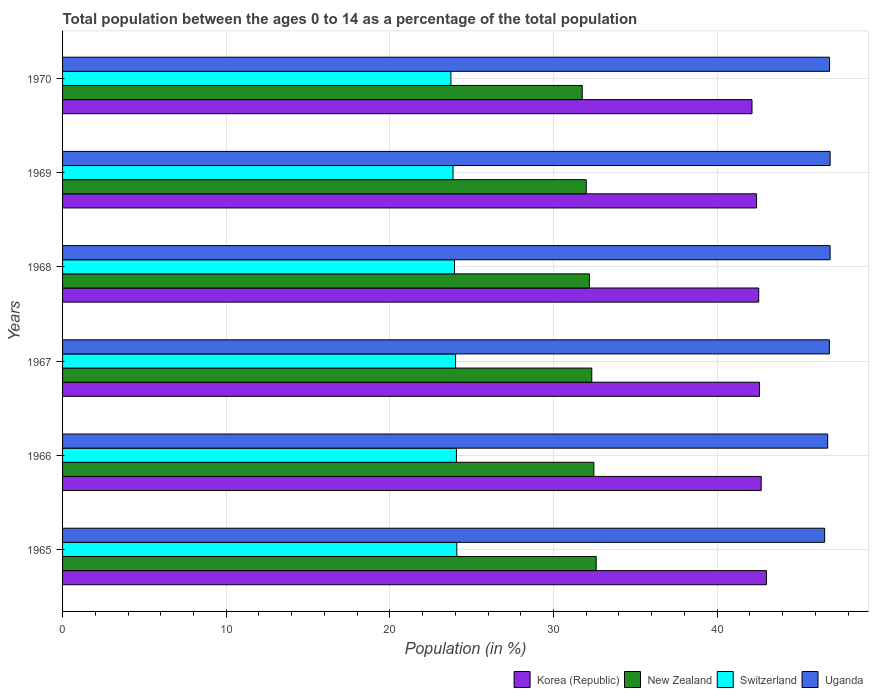Are the number of bars on each tick of the Y-axis equal?
Provide a succinct answer. Yes. How many bars are there on the 1st tick from the top?
Your answer should be compact. 4. What is the label of the 4th group of bars from the top?
Your answer should be very brief. 1967. In how many cases, is the number of bars for a given year not equal to the number of legend labels?
Ensure brevity in your answer.  0. What is the percentage of the population ages 0 to 14 in Uganda in 1965?
Provide a short and direct response. 46.57. Across all years, what is the maximum percentage of the population ages 0 to 14 in New Zealand?
Keep it short and to the point. 32.61. Across all years, what is the minimum percentage of the population ages 0 to 14 in Uganda?
Keep it short and to the point. 46.57. In which year was the percentage of the population ages 0 to 14 in Korea (Republic) maximum?
Provide a succinct answer. 1965. What is the total percentage of the population ages 0 to 14 in Korea (Republic) in the graph?
Keep it short and to the point. 255.38. What is the difference between the percentage of the population ages 0 to 14 in Uganda in 1965 and that in 1970?
Keep it short and to the point. -0.3. What is the difference between the percentage of the population ages 0 to 14 in Uganda in 1965 and the percentage of the population ages 0 to 14 in Switzerland in 1968?
Offer a terse response. 22.62. What is the average percentage of the population ages 0 to 14 in Uganda per year?
Provide a succinct answer. 46.81. In the year 1969, what is the difference between the percentage of the population ages 0 to 14 in New Zealand and percentage of the population ages 0 to 14 in Uganda?
Keep it short and to the point. -14.9. In how many years, is the percentage of the population ages 0 to 14 in Switzerland greater than 12 ?
Your response must be concise. 6. What is the ratio of the percentage of the population ages 0 to 14 in Uganda in 1967 to that in 1968?
Keep it short and to the point. 1. Is the difference between the percentage of the population ages 0 to 14 in New Zealand in 1969 and 1970 greater than the difference between the percentage of the population ages 0 to 14 in Uganda in 1969 and 1970?
Your answer should be compact. Yes. What is the difference between the highest and the second highest percentage of the population ages 0 to 14 in New Zealand?
Your answer should be compact. 0.14. What is the difference between the highest and the lowest percentage of the population ages 0 to 14 in Switzerland?
Keep it short and to the point. 0.36. Is it the case that in every year, the sum of the percentage of the population ages 0 to 14 in Switzerland and percentage of the population ages 0 to 14 in New Zealand is greater than the sum of percentage of the population ages 0 to 14 in Uganda and percentage of the population ages 0 to 14 in Korea (Republic)?
Give a very brief answer. No. What does the 2nd bar from the top in 1966 represents?
Your response must be concise. Switzerland. What does the 1st bar from the bottom in 1969 represents?
Offer a terse response. Korea (Republic). Is it the case that in every year, the sum of the percentage of the population ages 0 to 14 in Uganda and percentage of the population ages 0 to 14 in Switzerland is greater than the percentage of the population ages 0 to 14 in Korea (Republic)?
Provide a succinct answer. Yes. Are all the bars in the graph horizontal?
Your answer should be compact. Yes. Are the values on the major ticks of X-axis written in scientific E-notation?
Keep it short and to the point. No. Does the graph contain any zero values?
Make the answer very short. No. Does the graph contain grids?
Provide a short and direct response. Yes. Where does the legend appear in the graph?
Provide a succinct answer. Bottom right. How many legend labels are there?
Ensure brevity in your answer.  4. What is the title of the graph?
Your response must be concise. Total population between the ages 0 to 14 as a percentage of the total population. Does "North America" appear as one of the legend labels in the graph?
Your answer should be very brief. No. What is the label or title of the Y-axis?
Your response must be concise. Years. What is the Population (in %) in Korea (Republic) in 1965?
Provide a succinct answer. 43.01. What is the Population (in %) of New Zealand in 1965?
Make the answer very short. 32.61. What is the Population (in %) of Switzerland in 1965?
Your answer should be compact. 24.09. What is the Population (in %) of Uganda in 1965?
Your answer should be compact. 46.57. What is the Population (in %) in Korea (Republic) in 1966?
Give a very brief answer. 42.69. What is the Population (in %) in New Zealand in 1966?
Offer a very short reply. 32.47. What is the Population (in %) in Switzerland in 1966?
Ensure brevity in your answer.  24.07. What is the Population (in %) in Uganda in 1966?
Keep it short and to the point. 46.76. What is the Population (in %) in Korea (Republic) in 1967?
Give a very brief answer. 42.59. What is the Population (in %) of New Zealand in 1967?
Ensure brevity in your answer.  32.34. What is the Population (in %) of Switzerland in 1967?
Make the answer very short. 24.02. What is the Population (in %) in Uganda in 1967?
Your answer should be very brief. 46.86. What is the Population (in %) in Korea (Republic) in 1968?
Give a very brief answer. 42.54. What is the Population (in %) in New Zealand in 1968?
Ensure brevity in your answer.  32.19. What is the Population (in %) of Switzerland in 1968?
Your answer should be compact. 23.95. What is the Population (in %) in Uganda in 1968?
Ensure brevity in your answer.  46.9. What is the Population (in %) of Korea (Republic) in 1969?
Your answer should be compact. 42.41. What is the Population (in %) in New Zealand in 1969?
Provide a short and direct response. 32. What is the Population (in %) in Switzerland in 1969?
Your response must be concise. 23.86. What is the Population (in %) of Uganda in 1969?
Provide a short and direct response. 46.9. What is the Population (in %) of Korea (Republic) in 1970?
Provide a succinct answer. 42.13. What is the Population (in %) of New Zealand in 1970?
Give a very brief answer. 31.76. What is the Population (in %) of Switzerland in 1970?
Offer a terse response. 23.73. What is the Population (in %) in Uganda in 1970?
Your response must be concise. 46.87. Across all years, what is the maximum Population (in %) in Korea (Republic)?
Provide a succinct answer. 43.01. Across all years, what is the maximum Population (in %) of New Zealand?
Ensure brevity in your answer.  32.61. Across all years, what is the maximum Population (in %) of Switzerland?
Ensure brevity in your answer.  24.09. Across all years, what is the maximum Population (in %) of Uganda?
Make the answer very short. 46.9. Across all years, what is the minimum Population (in %) of Korea (Republic)?
Your answer should be compact. 42.13. Across all years, what is the minimum Population (in %) in New Zealand?
Provide a succinct answer. 31.76. Across all years, what is the minimum Population (in %) of Switzerland?
Your answer should be very brief. 23.73. Across all years, what is the minimum Population (in %) of Uganda?
Give a very brief answer. 46.57. What is the total Population (in %) in Korea (Republic) in the graph?
Offer a terse response. 255.38. What is the total Population (in %) in New Zealand in the graph?
Ensure brevity in your answer.  193.37. What is the total Population (in %) of Switzerland in the graph?
Ensure brevity in your answer.  143.72. What is the total Population (in %) of Uganda in the graph?
Provide a short and direct response. 280.86. What is the difference between the Population (in %) in Korea (Republic) in 1965 and that in 1966?
Ensure brevity in your answer.  0.32. What is the difference between the Population (in %) of New Zealand in 1965 and that in 1966?
Offer a terse response. 0.14. What is the difference between the Population (in %) of Switzerland in 1965 and that in 1966?
Your answer should be very brief. 0.02. What is the difference between the Population (in %) in Uganda in 1965 and that in 1966?
Your answer should be very brief. -0.19. What is the difference between the Population (in %) in Korea (Republic) in 1965 and that in 1967?
Make the answer very short. 0.42. What is the difference between the Population (in %) of New Zealand in 1965 and that in 1967?
Your response must be concise. 0.27. What is the difference between the Population (in %) in Switzerland in 1965 and that in 1967?
Your response must be concise. 0.07. What is the difference between the Population (in %) in Uganda in 1965 and that in 1967?
Offer a very short reply. -0.29. What is the difference between the Population (in %) in Korea (Republic) in 1965 and that in 1968?
Keep it short and to the point. 0.47. What is the difference between the Population (in %) of New Zealand in 1965 and that in 1968?
Your response must be concise. 0.42. What is the difference between the Population (in %) of Switzerland in 1965 and that in 1968?
Make the answer very short. 0.14. What is the difference between the Population (in %) of Uganda in 1965 and that in 1968?
Provide a succinct answer. -0.33. What is the difference between the Population (in %) of Korea (Republic) in 1965 and that in 1969?
Your answer should be very brief. 0.61. What is the difference between the Population (in %) of New Zealand in 1965 and that in 1969?
Provide a succinct answer. 0.61. What is the difference between the Population (in %) in Switzerland in 1965 and that in 1969?
Offer a terse response. 0.23. What is the difference between the Population (in %) in Uganda in 1965 and that in 1969?
Give a very brief answer. -0.33. What is the difference between the Population (in %) of Korea (Republic) in 1965 and that in 1970?
Your answer should be compact. 0.88. What is the difference between the Population (in %) in New Zealand in 1965 and that in 1970?
Provide a short and direct response. 0.85. What is the difference between the Population (in %) in Switzerland in 1965 and that in 1970?
Your answer should be compact. 0.36. What is the difference between the Population (in %) in Uganda in 1965 and that in 1970?
Provide a succinct answer. -0.3. What is the difference between the Population (in %) in Korea (Republic) in 1966 and that in 1967?
Keep it short and to the point. 0.1. What is the difference between the Population (in %) in New Zealand in 1966 and that in 1967?
Offer a terse response. 0.13. What is the difference between the Population (in %) of Switzerland in 1966 and that in 1967?
Provide a succinct answer. 0.05. What is the difference between the Population (in %) of Uganda in 1966 and that in 1967?
Provide a succinct answer. -0.1. What is the difference between the Population (in %) in Korea (Republic) in 1966 and that in 1968?
Provide a succinct answer. 0.15. What is the difference between the Population (in %) in New Zealand in 1966 and that in 1968?
Provide a short and direct response. 0.27. What is the difference between the Population (in %) of Switzerland in 1966 and that in 1968?
Offer a very short reply. 0.12. What is the difference between the Population (in %) of Uganda in 1966 and that in 1968?
Make the answer very short. -0.15. What is the difference between the Population (in %) in Korea (Republic) in 1966 and that in 1969?
Your response must be concise. 0.28. What is the difference between the Population (in %) of New Zealand in 1966 and that in 1969?
Ensure brevity in your answer.  0.46. What is the difference between the Population (in %) of Switzerland in 1966 and that in 1969?
Your answer should be very brief. 0.21. What is the difference between the Population (in %) of Uganda in 1966 and that in 1969?
Your answer should be very brief. -0.15. What is the difference between the Population (in %) of Korea (Republic) in 1966 and that in 1970?
Your answer should be very brief. 0.56. What is the difference between the Population (in %) in New Zealand in 1966 and that in 1970?
Keep it short and to the point. 0.71. What is the difference between the Population (in %) of Switzerland in 1966 and that in 1970?
Your response must be concise. 0.34. What is the difference between the Population (in %) in Uganda in 1966 and that in 1970?
Give a very brief answer. -0.11. What is the difference between the Population (in %) of Korea (Republic) in 1967 and that in 1968?
Keep it short and to the point. 0.05. What is the difference between the Population (in %) of New Zealand in 1967 and that in 1968?
Provide a short and direct response. 0.14. What is the difference between the Population (in %) of Switzerland in 1967 and that in 1968?
Make the answer very short. 0.07. What is the difference between the Population (in %) in Uganda in 1967 and that in 1968?
Make the answer very short. -0.04. What is the difference between the Population (in %) in Korea (Republic) in 1967 and that in 1969?
Make the answer very short. 0.18. What is the difference between the Population (in %) of New Zealand in 1967 and that in 1969?
Offer a very short reply. 0.34. What is the difference between the Population (in %) in Switzerland in 1967 and that in 1969?
Provide a short and direct response. 0.16. What is the difference between the Population (in %) of Uganda in 1967 and that in 1969?
Ensure brevity in your answer.  -0.04. What is the difference between the Population (in %) in Korea (Republic) in 1967 and that in 1970?
Your answer should be compact. 0.46. What is the difference between the Population (in %) of New Zealand in 1967 and that in 1970?
Your answer should be compact. 0.58. What is the difference between the Population (in %) of Switzerland in 1967 and that in 1970?
Keep it short and to the point. 0.29. What is the difference between the Population (in %) in Uganda in 1967 and that in 1970?
Your answer should be very brief. -0.01. What is the difference between the Population (in %) of Korea (Republic) in 1968 and that in 1969?
Your answer should be very brief. 0.13. What is the difference between the Population (in %) in New Zealand in 1968 and that in 1969?
Keep it short and to the point. 0.19. What is the difference between the Population (in %) in Switzerland in 1968 and that in 1969?
Provide a short and direct response. 0.09. What is the difference between the Population (in %) in Uganda in 1968 and that in 1969?
Provide a succinct answer. -0. What is the difference between the Population (in %) in Korea (Republic) in 1968 and that in 1970?
Your answer should be compact. 0.41. What is the difference between the Population (in %) in New Zealand in 1968 and that in 1970?
Make the answer very short. 0.44. What is the difference between the Population (in %) of Switzerland in 1968 and that in 1970?
Give a very brief answer. 0.22. What is the difference between the Population (in %) in Uganda in 1968 and that in 1970?
Ensure brevity in your answer.  0.04. What is the difference between the Population (in %) of Korea (Republic) in 1969 and that in 1970?
Provide a succinct answer. 0.28. What is the difference between the Population (in %) of New Zealand in 1969 and that in 1970?
Your answer should be very brief. 0.24. What is the difference between the Population (in %) of Switzerland in 1969 and that in 1970?
Provide a short and direct response. 0.13. What is the difference between the Population (in %) of Uganda in 1969 and that in 1970?
Ensure brevity in your answer.  0.04. What is the difference between the Population (in %) in Korea (Republic) in 1965 and the Population (in %) in New Zealand in 1966?
Offer a terse response. 10.55. What is the difference between the Population (in %) of Korea (Republic) in 1965 and the Population (in %) of Switzerland in 1966?
Your response must be concise. 18.95. What is the difference between the Population (in %) in Korea (Republic) in 1965 and the Population (in %) in Uganda in 1966?
Provide a short and direct response. -3.74. What is the difference between the Population (in %) of New Zealand in 1965 and the Population (in %) of Switzerland in 1966?
Your answer should be very brief. 8.54. What is the difference between the Population (in %) of New Zealand in 1965 and the Population (in %) of Uganda in 1966?
Offer a terse response. -14.15. What is the difference between the Population (in %) in Switzerland in 1965 and the Population (in %) in Uganda in 1966?
Keep it short and to the point. -22.66. What is the difference between the Population (in %) of Korea (Republic) in 1965 and the Population (in %) of New Zealand in 1967?
Offer a very short reply. 10.68. What is the difference between the Population (in %) of Korea (Republic) in 1965 and the Population (in %) of Switzerland in 1967?
Offer a terse response. 19. What is the difference between the Population (in %) in Korea (Republic) in 1965 and the Population (in %) in Uganda in 1967?
Offer a terse response. -3.85. What is the difference between the Population (in %) of New Zealand in 1965 and the Population (in %) of Switzerland in 1967?
Provide a short and direct response. 8.59. What is the difference between the Population (in %) of New Zealand in 1965 and the Population (in %) of Uganda in 1967?
Your answer should be compact. -14.25. What is the difference between the Population (in %) of Switzerland in 1965 and the Population (in %) of Uganda in 1967?
Offer a very short reply. -22.77. What is the difference between the Population (in %) of Korea (Republic) in 1965 and the Population (in %) of New Zealand in 1968?
Your response must be concise. 10.82. What is the difference between the Population (in %) in Korea (Republic) in 1965 and the Population (in %) in Switzerland in 1968?
Keep it short and to the point. 19.06. What is the difference between the Population (in %) in Korea (Republic) in 1965 and the Population (in %) in Uganda in 1968?
Provide a short and direct response. -3.89. What is the difference between the Population (in %) in New Zealand in 1965 and the Population (in %) in Switzerland in 1968?
Your answer should be compact. 8.66. What is the difference between the Population (in %) in New Zealand in 1965 and the Population (in %) in Uganda in 1968?
Provide a succinct answer. -14.29. What is the difference between the Population (in %) in Switzerland in 1965 and the Population (in %) in Uganda in 1968?
Your answer should be very brief. -22.81. What is the difference between the Population (in %) in Korea (Republic) in 1965 and the Population (in %) in New Zealand in 1969?
Make the answer very short. 11.01. What is the difference between the Population (in %) of Korea (Republic) in 1965 and the Population (in %) of Switzerland in 1969?
Your answer should be compact. 19.15. What is the difference between the Population (in %) of Korea (Republic) in 1965 and the Population (in %) of Uganda in 1969?
Offer a terse response. -3.89. What is the difference between the Population (in %) in New Zealand in 1965 and the Population (in %) in Switzerland in 1969?
Your answer should be compact. 8.75. What is the difference between the Population (in %) of New Zealand in 1965 and the Population (in %) of Uganda in 1969?
Offer a terse response. -14.29. What is the difference between the Population (in %) in Switzerland in 1965 and the Population (in %) in Uganda in 1969?
Offer a very short reply. -22.81. What is the difference between the Population (in %) of Korea (Republic) in 1965 and the Population (in %) of New Zealand in 1970?
Offer a terse response. 11.26. What is the difference between the Population (in %) in Korea (Republic) in 1965 and the Population (in %) in Switzerland in 1970?
Offer a terse response. 19.28. What is the difference between the Population (in %) of Korea (Republic) in 1965 and the Population (in %) of Uganda in 1970?
Ensure brevity in your answer.  -3.85. What is the difference between the Population (in %) of New Zealand in 1965 and the Population (in %) of Switzerland in 1970?
Provide a succinct answer. 8.88. What is the difference between the Population (in %) in New Zealand in 1965 and the Population (in %) in Uganda in 1970?
Ensure brevity in your answer.  -14.26. What is the difference between the Population (in %) in Switzerland in 1965 and the Population (in %) in Uganda in 1970?
Keep it short and to the point. -22.78. What is the difference between the Population (in %) of Korea (Republic) in 1966 and the Population (in %) of New Zealand in 1967?
Provide a succinct answer. 10.35. What is the difference between the Population (in %) of Korea (Republic) in 1966 and the Population (in %) of Switzerland in 1967?
Make the answer very short. 18.68. What is the difference between the Population (in %) in Korea (Republic) in 1966 and the Population (in %) in Uganda in 1967?
Your response must be concise. -4.17. What is the difference between the Population (in %) in New Zealand in 1966 and the Population (in %) in Switzerland in 1967?
Your answer should be very brief. 8.45. What is the difference between the Population (in %) of New Zealand in 1966 and the Population (in %) of Uganda in 1967?
Make the answer very short. -14.39. What is the difference between the Population (in %) in Switzerland in 1966 and the Population (in %) in Uganda in 1967?
Offer a very short reply. -22.79. What is the difference between the Population (in %) in Korea (Republic) in 1966 and the Population (in %) in New Zealand in 1968?
Your response must be concise. 10.5. What is the difference between the Population (in %) in Korea (Republic) in 1966 and the Population (in %) in Switzerland in 1968?
Give a very brief answer. 18.74. What is the difference between the Population (in %) in Korea (Republic) in 1966 and the Population (in %) in Uganda in 1968?
Your answer should be compact. -4.21. What is the difference between the Population (in %) of New Zealand in 1966 and the Population (in %) of Switzerland in 1968?
Offer a very short reply. 8.51. What is the difference between the Population (in %) in New Zealand in 1966 and the Population (in %) in Uganda in 1968?
Your answer should be compact. -14.44. What is the difference between the Population (in %) of Switzerland in 1966 and the Population (in %) of Uganda in 1968?
Make the answer very short. -22.84. What is the difference between the Population (in %) of Korea (Republic) in 1966 and the Population (in %) of New Zealand in 1969?
Keep it short and to the point. 10.69. What is the difference between the Population (in %) of Korea (Republic) in 1966 and the Population (in %) of Switzerland in 1969?
Keep it short and to the point. 18.83. What is the difference between the Population (in %) of Korea (Republic) in 1966 and the Population (in %) of Uganda in 1969?
Your answer should be very brief. -4.21. What is the difference between the Population (in %) in New Zealand in 1966 and the Population (in %) in Switzerland in 1969?
Ensure brevity in your answer.  8.61. What is the difference between the Population (in %) of New Zealand in 1966 and the Population (in %) of Uganda in 1969?
Offer a very short reply. -14.44. What is the difference between the Population (in %) of Switzerland in 1966 and the Population (in %) of Uganda in 1969?
Provide a succinct answer. -22.84. What is the difference between the Population (in %) in Korea (Republic) in 1966 and the Population (in %) in New Zealand in 1970?
Give a very brief answer. 10.94. What is the difference between the Population (in %) in Korea (Republic) in 1966 and the Population (in %) in Switzerland in 1970?
Offer a terse response. 18.96. What is the difference between the Population (in %) in Korea (Republic) in 1966 and the Population (in %) in Uganda in 1970?
Make the answer very short. -4.17. What is the difference between the Population (in %) in New Zealand in 1966 and the Population (in %) in Switzerland in 1970?
Your answer should be very brief. 8.74. What is the difference between the Population (in %) of New Zealand in 1966 and the Population (in %) of Uganda in 1970?
Offer a very short reply. -14.4. What is the difference between the Population (in %) of Switzerland in 1966 and the Population (in %) of Uganda in 1970?
Provide a short and direct response. -22.8. What is the difference between the Population (in %) in Korea (Republic) in 1967 and the Population (in %) in New Zealand in 1968?
Offer a very short reply. 10.39. What is the difference between the Population (in %) in Korea (Republic) in 1967 and the Population (in %) in Switzerland in 1968?
Your answer should be compact. 18.64. What is the difference between the Population (in %) in Korea (Republic) in 1967 and the Population (in %) in Uganda in 1968?
Give a very brief answer. -4.31. What is the difference between the Population (in %) in New Zealand in 1967 and the Population (in %) in Switzerland in 1968?
Ensure brevity in your answer.  8.39. What is the difference between the Population (in %) in New Zealand in 1967 and the Population (in %) in Uganda in 1968?
Offer a very short reply. -14.56. What is the difference between the Population (in %) of Switzerland in 1967 and the Population (in %) of Uganda in 1968?
Your response must be concise. -22.89. What is the difference between the Population (in %) of Korea (Republic) in 1967 and the Population (in %) of New Zealand in 1969?
Offer a terse response. 10.59. What is the difference between the Population (in %) in Korea (Republic) in 1967 and the Population (in %) in Switzerland in 1969?
Your response must be concise. 18.73. What is the difference between the Population (in %) of Korea (Republic) in 1967 and the Population (in %) of Uganda in 1969?
Your answer should be compact. -4.31. What is the difference between the Population (in %) in New Zealand in 1967 and the Population (in %) in Switzerland in 1969?
Give a very brief answer. 8.48. What is the difference between the Population (in %) in New Zealand in 1967 and the Population (in %) in Uganda in 1969?
Your answer should be very brief. -14.57. What is the difference between the Population (in %) of Switzerland in 1967 and the Population (in %) of Uganda in 1969?
Make the answer very short. -22.89. What is the difference between the Population (in %) in Korea (Republic) in 1967 and the Population (in %) in New Zealand in 1970?
Give a very brief answer. 10.83. What is the difference between the Population (in %) in Korea (Republic) in 1967 and the Population (in %) in Switzerland in 1970?
Offer a very short reply. 18.86. What is the difference between the Population (in %) of Korea (Republic) in 1967 and the Population (in %) of Uganda in 1970?
Keep it short and to the point. -4.28. What is the difference between the Population (in %) of New Zealand in 1967 and the Population (in %) of Switzerland in 1970?
Your answer should be very brief. 8.61. What is the difference between the Population (in %) of New Zealand in 1967 and the Population (in %) of Uganda in 1970?
Offer a terse response. -14.53. What is the difference between the Population (in %) of Switzerland in 1967 and the Population (in %) of Uganda in 1970?
Provide a short and direct response. -22.85. What is the difference between the Population (in %) in Korea (Republic) in 1968 and the Population (in %) in New Zealand in 1969?
Keep it short and to the point. 10.54. What is the difference between the Population (in %) in Korea (Republic) in 1968 and the Population (in %) in Switzerland in 1969?
Offer a very short reply. 18.68. What is the difference between the Population (in %) in Korea (Republic) in 1968 and the Population (in %) in Uganda in 1969?
Keep it short and to the point. -4.36. What is the difference between the Population (in %) of New Zealand in 1968 and the Population (in %) of Switzerland in 1969?
Ensure brevity in your answer.  8.33. What is the difference between the Population (in %) of New Zealand in 1968 and the Population (in %) of Uganda in 1969?
Offer a very short reply. -14.71. What is the difference between the Population (in %) in Switzerland in 1968 and the Population (in %) in Uganda in 1969?
Provide a short and direct response. -22.95. What is the difference between the Population (in %) of Korea (Republic) in 1968 and the Population (in %) of New Zealand in 1970?
Provide a succinct answer. 10.78. What is the difference between the Population (in %) in Korea (Republic) in 1968 and the Population (in %) in Switzerland in 1970?
Offer a very short reply. 18.81. What is the difference between the Population (in %) of Korea (Republic) in 1968 and the Population (in %) of Uganda in 1970?
Keep it short and to the point. -4.33. What is the difference between the Population (in %) in New Zealand in 1968 and the Population (in %) in Switzerland in 1970?
Keep it short and to the point. 8.46. What is the difference between the Population (in %) in New Zealand in 1968 and the Population (in %) in Uganda in 1970?
Your answer should be very brief. -14.67. What is the difference between the Population (in %) of Switzerland in 1968 and the Population (in %) of Uganda in 1970?
Keep it short and to the point. -22.91. What is the difference between the Population (in %) of Korea (Republic) in 1969 and the Population (in %) of New Zealand in 1970?
Your response must be concise. 10.65. What is the difference between the Population (in %) of Korea (Republic) in 1969 and the Population (in %) of Switzerland in 1970?
Offer a terse response. 18.68. What is the difference between the Population (in %) of Korea (Republic) in 1969 and the Population (in %) of Uganda in 1970?
Give a very brief answer. -4.46. What is the difference between the Population (in %) of New Zealand in 1969 and the Population (in %) of Switzerland in 1970?
Ensure brevity in your answer.  8.27. What is the difference between the Population (in %) in New Zealand in 1969 and the Population (in %) in Uganda in 1970?
Give a very brief answer. -14.87. What is the difference between the Population (in %) in Switzerland in 1969 and the Population (in %) in Uganda in 1970?
Your response must be concise. -23.01. What is the average Population (in %) of Korea (Republic) per year?
Provide a short and direct response. 42.56. What is the average Population (in %) in New Zealand per year?
Your answer should be very brief. 32.23. What is the average Population (in %) of Switzerland per year?
Your answer should be compact. 23.95. What is the average Population (in %) of Uganda per year?
Provide a short and direct response. 46.81. In the year 1965, what is the difference between the Population (in %) of Korea (Republic) and Population (in %) of New Zealand?
Make the answer very short. 10.4. In the year 1965, what is the difference between the Population (in %) of Korea (Republic) and Population (in %) of Switzerland?
Ensure brevity in your answer.  18.92. In the year 1965, what is the difference between the Population (in %) of Korea (Republic) and Population (in %) of Uganda?
Your answer should be compact. -3.56. In the year 1965, what is the difference between the Population (in %) in New Zealand and Population (in %) in Switzerland?
Provide a short and direct response. 8.52. In the year 1965, what is the difference between the Population (in %) in New Zealand and Population (in %) in Uganda?
Give a very brief answer. -13.96. In the year 1965, what is the difference between the Population (in %) of Switzerland and Population (in %) of Uganda?
Give a very brief answer. -22.48. In the year 1966, what is the difference between the Population (in %) in Korea (Republic) and Population (in %) in New Zealand?
Offer a very short reply. 10.23. In the year 1966, what is the difference between the Population (in %) in Korea (Republic) and Population (in %) in Switzerland?
Offer a terse response. 18.63. In the year 1966, what is the difference between the Population (in %) of Korea (Republic) and Population (in %) of Uganda?
Offer a very short reply. -4.06. In the year 1966, what is the difference between the Population (in %) of New Zealand and Population (in %) of Switzerland?
Provide a succinct answer. 8.4. In the year 1966, what is the difference between the Population (in %) in New Zealand and Population (in %) in Uganda?
Offer a very short reply. -14.29. In the year 1966, what is the difference between the Population (in %) in Switzerland and Population (in %) in Uganda?
Ensure brevity in your answer.  -22.69. In the year 1967, what is the difference between the Population (in %) in Korea (Republic) and Population (in %) in New Zealand?
Keep it short and to the point. 10.25. In the year 1967, what is the difference between the Population (in %) of Korea (Republic) and Population (in %) of Switzerland?
Offer a terse response. 18.57. In the year 1967, what is the difference between the Population (in %) in Korea (Republic) and Population (in %) in Uganda?
Keep it short and to the point. -4.27. In the year 1967, what is the difference between the Population (in %) of New Zealand and Population (in %) of Switzerland?
Ensure brevity in your answer.  8.32. In the year 1967, what is the difference between the Population (in %) of New Zealand and Population (in %) of Uganda?
Offer a terse response. -14.52. In the year 1967, what is the difference between the Population (in %) in Switzerland and Population (in %) in Uganda?
Keep it short and to the point. -22.84. In the year 1968, what is the difference between the Population (in %) in Korea (Republic) and Population (in %) in New Zealand?
Provide a succinct answer. 10.35. In the year 1968, what is the difference between the Population (in %) in Korea (Republic) and Population (in %) in Switzerland?
Your answer should be very brief. 18.59. In the year 1968, what is the difference between the Population (in %) in Korea (Republic) and Population (in %) in Uganda?
Your answer should be compact. -4.36. In the year 1968, what is the difference between the Population (in %) in New Zealand and Population (in %) in Switzerland?
Give a very brief answer. 8.24. In the year 1968, what is the difference between the Population (in %) of New Zealand and Population (in %) of Uganda?
Your answer should be compact. -14.71. In the year 1968, what is the difference between the Population (in %) in Switzerland and Population (in %) in Uganda?
Keep it short and to the point. -22.95. In the year 1969, what is the difference between the Population (in %) of Korea (Republic) and Population (in %) of New Zealand?
Give a very brief answer. 10.41. In the year 1969, what is the difference between the Population (in %) in Korea (Republic) and Population (in %) in Switzerland?
Make the answer very short. 18.55. In the year 1969, what is the difference between the Population (in %) in Korea (Republic) and Population (in %) in Uganda?
Your answer should be compact. -4.49. In the year 1969, what is the difference between the Population (in %) of New Zealand and Population (in %) of Switzerland?
Keep it short and to the point. 8.14. In the year 1969, what is the difference between the Population (in %) in New Zealand and Population (in %) in Uganda?
Provide a short and direct response. -14.9. In the year 1969, what is the difference between the Population (in %) in Switzerland and Population (in %) in Uganda?
Make the answer very short. -23.04. In the year 1970, what is the difference between the Population (in %) of Korea (Republic) and Population (in %) of New Zealand?
Make the answer very short. 10.37. In the year 1970, what is the difference between the Population (in %) of Korea (Republic) and Population (in %) of Uganda?
Offer a very short reply. -4.74. In the year 1970, what is the difference between the Population (in %) of New Zealand and Population (in %) of Switzerland?
Ensure brevity in your answer.  8.03. In the year 1970, what is the difference between the Population (in %) in New Zealand and Population (in %) in Uganda?
Your answer should be very brief. -15.11. In the year 1970, what is the difference between the Population (in %) in Switzerland and Population (in %) in Uganda?
Give a very brief answer. -23.14. What is the ratio of the Population (in %) of Korea (Republic) in 1965 to that in 1966?
Provide a short and direct response. 1.01. What is the ratio of the Population (in %) of Switzerland in 1965 to that in 1966?
Offer a very short reply. 1. What is the ratio of the Population (in %) of New Zealand in 1965 to that in 1967?
Give a very brief answer. 1.01. What is the ratio of the Population (in %) of Korea (Republic) in 1965 to that in 1968?
Your answer should be compact. 1.01. What is the ratio of the Population (in %) of New Zealand in 1965 to that in 1968?
Provide a short and direct response. 1.01. What is the ratio of the Population (in %) of Korea (Republic) in 1965 to that in 1969?
Your answer should be compact. 1.01. What is the ratio of the Population (in %) in Switzerland in 1965 to that in 1969?
Your response must be concise. 1.01. What is the ratio of the Population (in %) of Korea (Republic) in 1965 to that in 1970?
Give a very brief answer. 1.02. What is the ratio of the Population (in %) in New Zealand in 1965 to that in 1970?
Keep it short and to the point. 1.03. What is the ratio of the Population (in %) of Switzerland in 1965 to that in 1970?
Offer a terse response. 1.02. What is the ratio of the Population (in %) in Uganda in 1965 to that in 1970?
Your answer should be very brief. 0.99. What is the ratio of the Population (in %) in Korea (Republic) in 1966 to that in 1967?
Offer a very short reply. 1. What is the ratio of the Population (in %) in Switzerland in 1966 to that in 1967?
Provide a succinct answer. 1. What is the ratio of the Population (in %) of Uganda in 1966 to that in 1967?
Your response must be concise. 1. What is the ratio of the Population (in %) in Korea (Republic) in 1966 to that in 1968?
Offer a very short reply. 1. What is the ratio of the Population (in %) in New Zealand in 1966 to that in 1968?
Your response must be concise. 1.01. What is the ratio of the Population (in %) of Uganda in 1966 to that in 1968?
Provide a succinct answer. 1. What is the ratio of the Population (in %) of New Zealand in 1966 to that in 1969?
Your response must be concise. 1.01. What is the ratio of the Population (in %) in Switzerland in 1966 to that in 1969?
Your answer should be compact. 1.01. What is the ratio of the Population (in %) in Korea (Republic) in 1966 to that in 1970?
Your answer should be very brief. 1.01. What is the ratio of the Population (in %) in New Zealand in 1966 to that in 1970?
Your answer should be very brief. 1.02. What is the ratio of the Population (in %) of Switzerland in 1966 to that in 1970?
Provide a succinct answer. 1.01. What is the ratio of the Population (in %) in Uganda in 1966 to that in 1970?
Your answer should be very brief. 1. What is the ratio of the Population (in %) of Korea (Republic) in 1967 to that in 1968?
Offer a very short reply. 1. What is the ratio of the Population (in %) of Uganda in 1967 to that in 1968?
Your response must be concise. 1. What is the ratio of the Population (in %) of New Zealand in 1967 to that in 1969?
Give a very brief answer. 1.01. What is the ratio of the Population (in %) of Switzerland in 1967 to that in 1969?
Provide a succinct answer. 1.01. What is the ratio of the Population (in %) of Uganda in 1967 to that in 1969?
Offer a terse response. 1. What is the ratio of the Population (in %) of Korea (Republic) in 1967 to that in 1970?
Give a very brief answer. 1.01. What is the ratio of the Population (in %) of New Zealand in 1967 to that in 1970?
Ensure brevity in your answer.  1.02. What is the ratio of the Population (in %) of Switzerland in 1967 to that in 1970?
Provide a succinct answer. 1.01. What is the ratio of the Population (in %) of Uganda in 1967 to that in 1970?
Provide a short and direct response. 1. What is the ratio of the Population (in %) of New Zealand in 1968 to that in 1969?
Ensure brevity in your answer.  1.01. What is the ratio of the Population (in %) of Switzerland in 1968 to that in 1969?
Offer a very short reply. 1. What is the ratio of the Population (in %) in Uganda in 1968 to that in 1969?
Ensure brevity in your answer.  1. What is the ratio of the Population (in %) in Korea (Republic) in 1968 to that in 1970?
Your answer should be very brief. 1.01. What is the ratio of the Population (in %) in New Zealand in 1968 to that in 1970?
Provide a short and direct response. 1.01. What is the ratio of the Population (in %) in Switzerland in 1968 to that in 1970?
Ensure brevity in your answer.  1.01. What is the ratio of the Population (in %) in Uganda in 1968 to that in 1970?
Provide a succinct answer. 1. What is the ratio of the Population (in %) in Korea (Republic) in 1969 to that in 1970?
Keep it short and to the point. 1.01. What is the ratio of the Population (in %) in New Zealand in 1969 to that in 1970?
Your answer should be compact. 1.01. What is the ratio of the Population (in %) of Switzerland in 1969 to that in 1970?
Offer a very short reply. 1.01. What is the difference between the highest and the second highest Population (in %) in Korea (Republic)?
Offer a terse response. 0.32. What is the difference between the highest and the second highest Population (in %) in New Zealand?
Offer a terse response. 0.14. What is the difference between the highest and the second highest Population (in %) of Switzerland?
Keep it short and to the point. 0.02. What is the difference between the highest and the second highest Population (in %) in Uganda?
Make the answer very short. 0. What is the difference between the highest and the lowest Population (in %) of Korea (Republic)?
Your response must be concise. 0.88. What is the difference between the highest and the lowest Population (in %) in New Zealand?
Give a very brief answer. 0.85. What is the difference between the highest and the lowest Population (in %) in Switzerland?
Offer a very short reply. 0.36. What is the difference between the highest and the lowest Population (in %) of Uganda?
Offer a terse response. 0.33. 